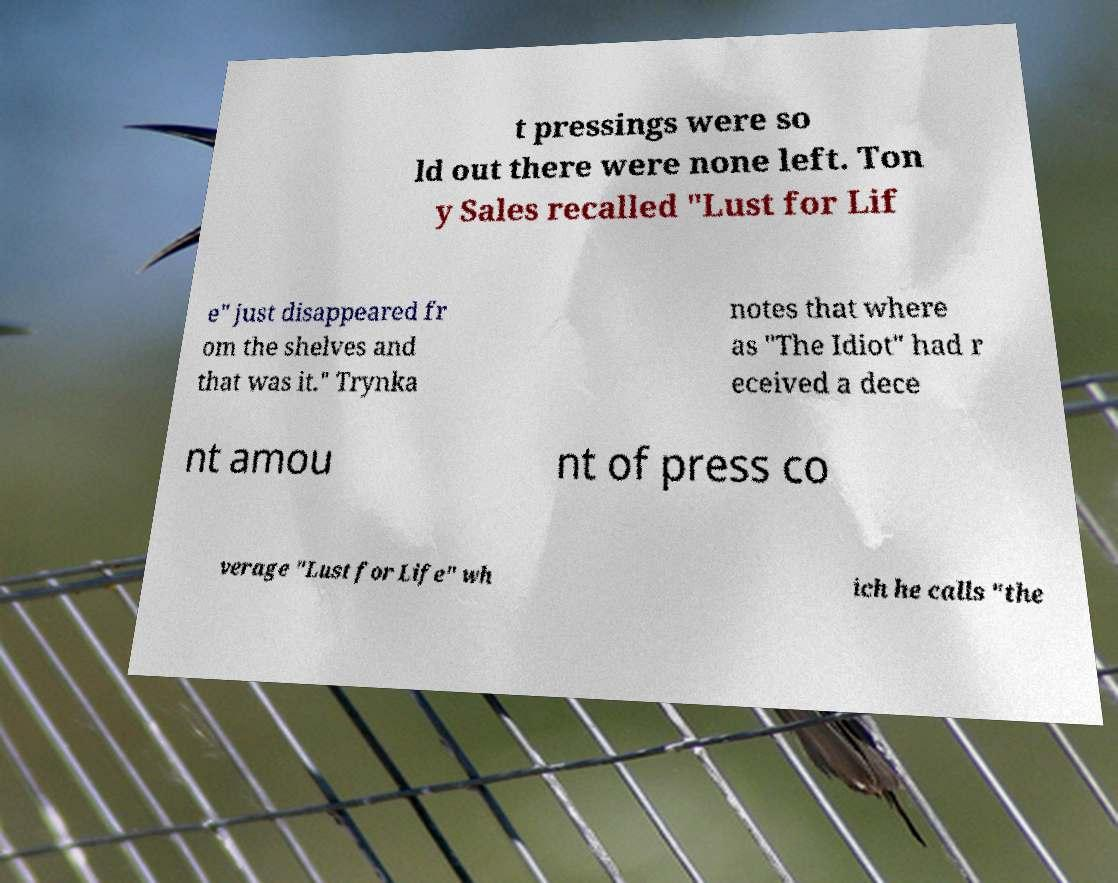For documentation purposes, I need the text within this image transcribed. Could you provide that? t pressings were so ld out there were none left. Ton y Sales recalled "Lust for Lif e" just disappeared fr om the shelves and that was it." Trynka notes that where as "The Idiot" had r eceived a dece nt amou nt of press co verage "Lust for Life" wh ich he calls "the 